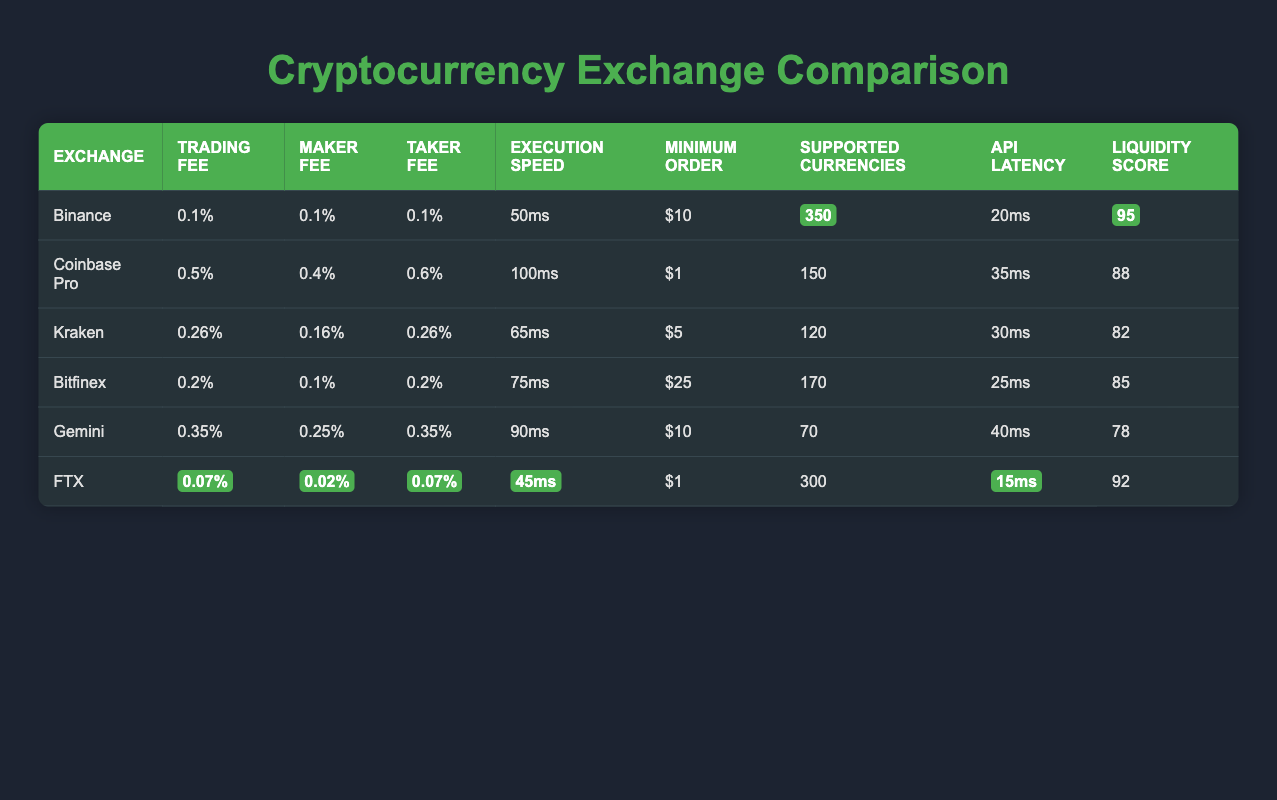What is the minimum order amount for FTX? The minimum order amount for FTX is indicated in the table as "$1."
Answer: $1 Which exchange has the lowest trading fee? In the table, FTX shows a trading fee of "0.07%", which is lower than all other exchanges listed.
Answer: 0.07% How fast does Binance execute trades compared to Gemini? Binance executes trades at "50ms," while Gemini has an execution speed of "90ms." Therefore, Binance is faster than Gemini.
Answer: Binance is faster What is the average liquidity score of the exchanges listed? The liquidity scores are 95 (Binance), 88 (Coinbase Pro), 82 (Kraken), 85 (Bitfinex), 78 (Gemini), and 92 (FTX). Adding these together gives 520, and dividing by the number of exchanges (6) gives an average of approximately 86.67.
Answer: 86.67 Is the API latency for Kraken less than that of Gemini? The API latency for Kraken is "30ms," while for Gemini it is "40ms." Since 30ms is less than 40ms, the statement is true.
Answer: Yes Which exchange supports more currencies, Binance or FTX? The table indicates that Binance supports 350 currencies and FTX supports 300 currencies. Therefore, Binance supports more currencies than FTX.
Answer: Binance supports more currencies What is the difference in execution speed between Bitfinex and Kraken? Bitfinex has an execution speed of "75ms," and Kraken has "65ms." Calculating the difference gives 75ms - 65ms = 10ms.
Answer: 10ms Does Coinbase Pro have a higher maker fee than Kraken? Coinbase Pro has a maker fee of "0.4%" while Kraken's is "0.16%." Since 0.4% is greater than 0.16%, the statement is true.
Answer: Yes Which exchange has the highest liquidity score? From the table, Binance has the highest liquidity score at "95," which is higher than all other exchanges listed.
Answer: Binance 